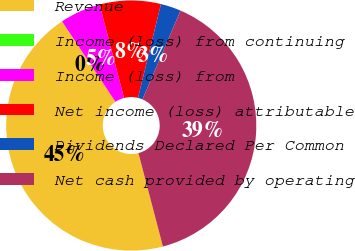<chart> <loc_0><loc_0><loc_500><loc_500><pie_chart><fcel>Revenue<fcel>Income (loss) from continuing<fcel>Income (loss) from<fcel>Net income (loss) attributable<fcel>Dividends Declared Per Common<fcel>Net cash provided by operating<nl><fcel>44.74%<fcel>0.0%<fcel>5.26%<fcel>7.89%<fcel>2.63%<fcel>39.47%<nl></chart> 